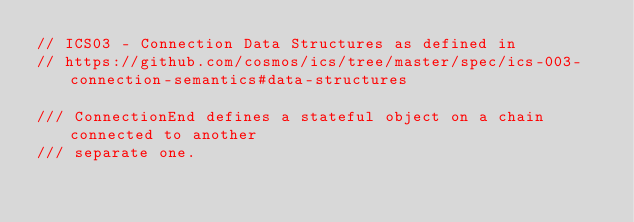Convert code to text. <code><loc_0><loc_0><loc_500><loc_500><_Rust_>// ICS03 - Connection Data Structures as defined in
// https://github.com/cosmos/ics/tree/master/spec/ics-003-connection-semantics#data-structures

/// ConnectionEnd defines a stateful object on a chain connected to another
/// separate one.</code> 